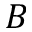<formula> <loc_0><loc_0><loc_500><loc_500>B</formula> 